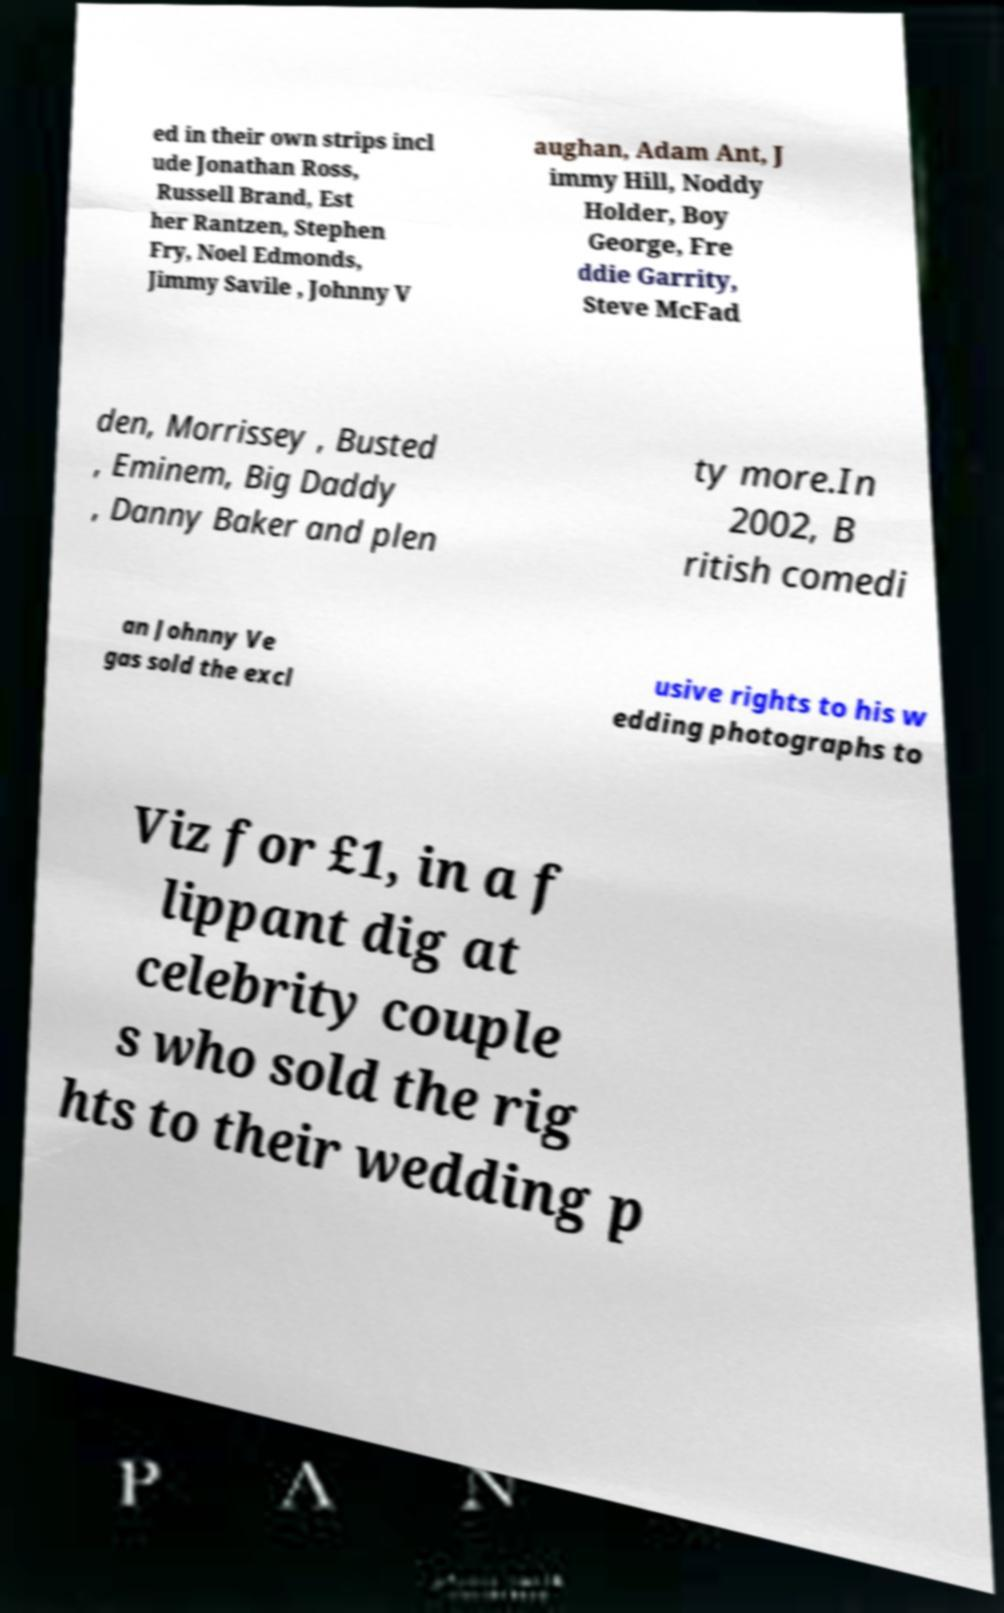I need the written content from this picture converted into text. Can you do that? ed in their own strips incl ude Jonathan Ross, Russell Brand, Est her Rantzen, Stephen Fry, Noel Edmonds, Jimmy Savile , Johnny V aughan, Adam Ant, J immy Hill, Noddy Holder, Boy George, Fre ddie Garrity, Steve McFad den, Morrissey , Busted , Eminem, Big Daddy , Danny Baker and plen ty more.In 2002, B ritish comedi an Johnny Ve gas sold the excl usive rights to his w edding photographs to Viz for £1, in a f lippant dig at celebrity couple s who sold the rig hts to their wedding p 